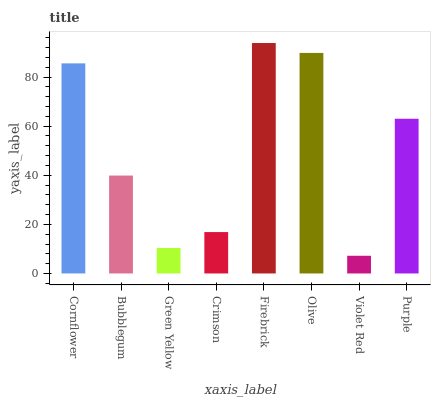Is Violet Red the minimum?
Answer yes or no. Yes. Is Firebrick the maximum?
Answer yes or no. Yes. Is Bubblegum the minimum?
Answer yes or no. No. Is Bubblegum the maximum?
Answer yes or no. No. Is Cornflower greater than Bubblegum?
Answer yes or no. Yes. Is Bubblegum less than Cornflower?
Answer yes or no. Yes. Is Bubblegum greater than Cornflower?
Answer yes or no. No. Is Cornflower less than Bubblegum?
Answer yes or no. No. Is Purple the high median?
Answer yes or no. Yes. Is Bubblegum the low median?
Answer yes or no. Yes. Is Firebrick the high median?
Answer yes or no. No. Is Olive the low median?
Answer yes or no. No. 